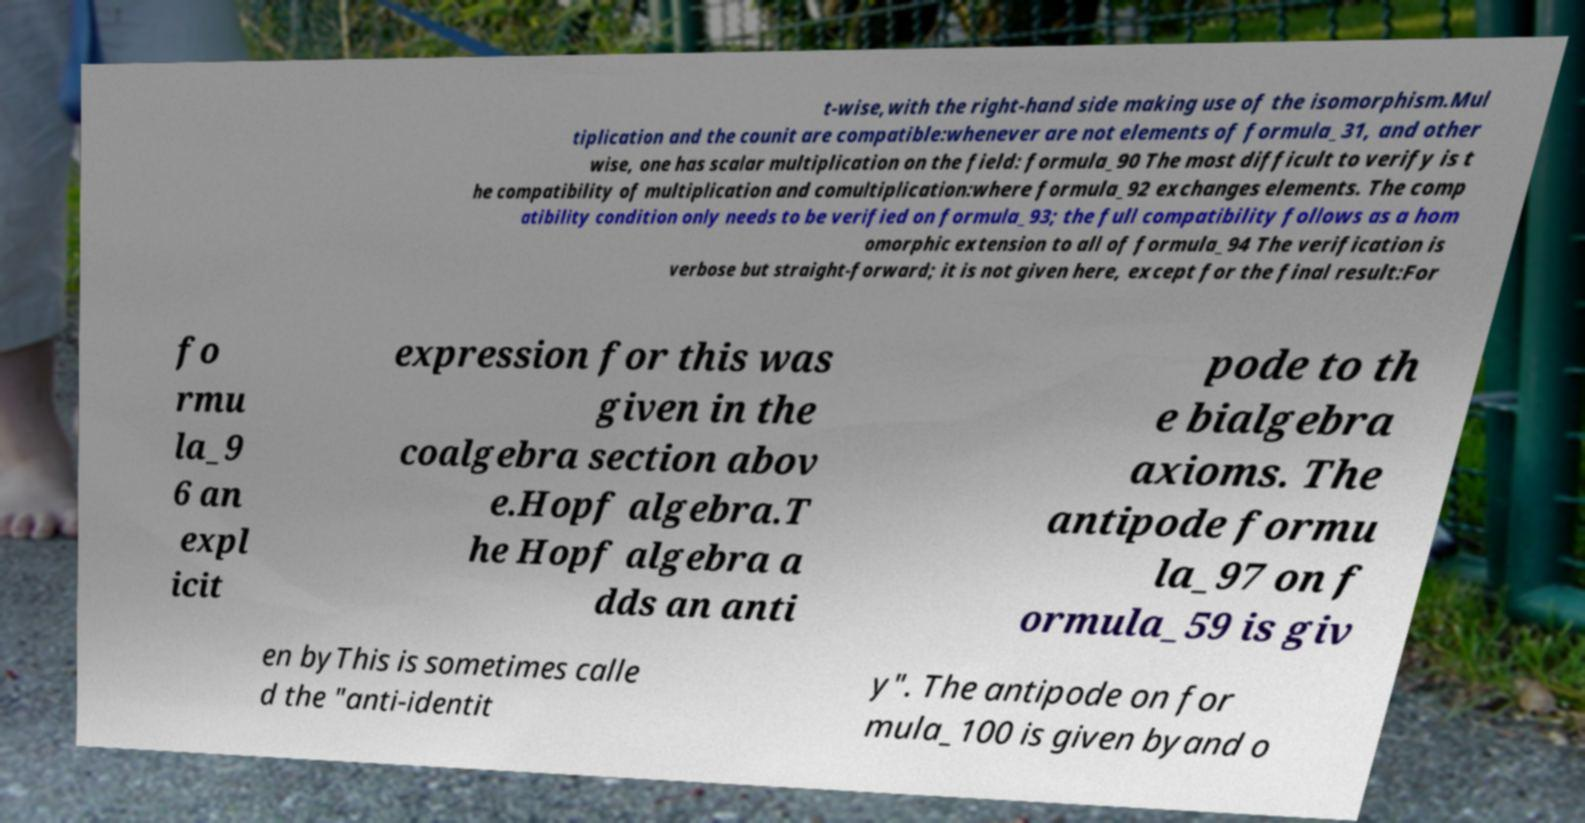Please identify and transcribe the text found in this image. t-wise,with the right-hand side making use of the isomorphism.Mul tiplication and the counit are compatible:whenever are not elements of formula_31, and other wise, one has scalar multiplication on the field: formula_90 The most difficult to verify is t he compatibility of multiplication and comultiplication:where formula_92 exchanges elements. The comp atibility condition only needs to be verified on formula_93; the full compatibility follows as a hom omorphic extension to all of formula_94 The verification is verbose but straight-forward; it is not given here, except for the final result:For fo rmu la_9 6 an expl icit expression for this was given in the coalgebra section abov e.Hopf algebra.T he Hopf algebra a dds an anti pode to th e bialgebra axioms. The antipode formu la_97 on f ormula_59 is giv en byThis is sometimes calle d the "anti-identit y". The antipode on for mula_100 is given byand o 